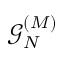Convert formula to latex. <formula><loc_0><loc_0><loc_500><loc_500>\mathcal { G } _ { N } ^ { ( M ) }</formula> 